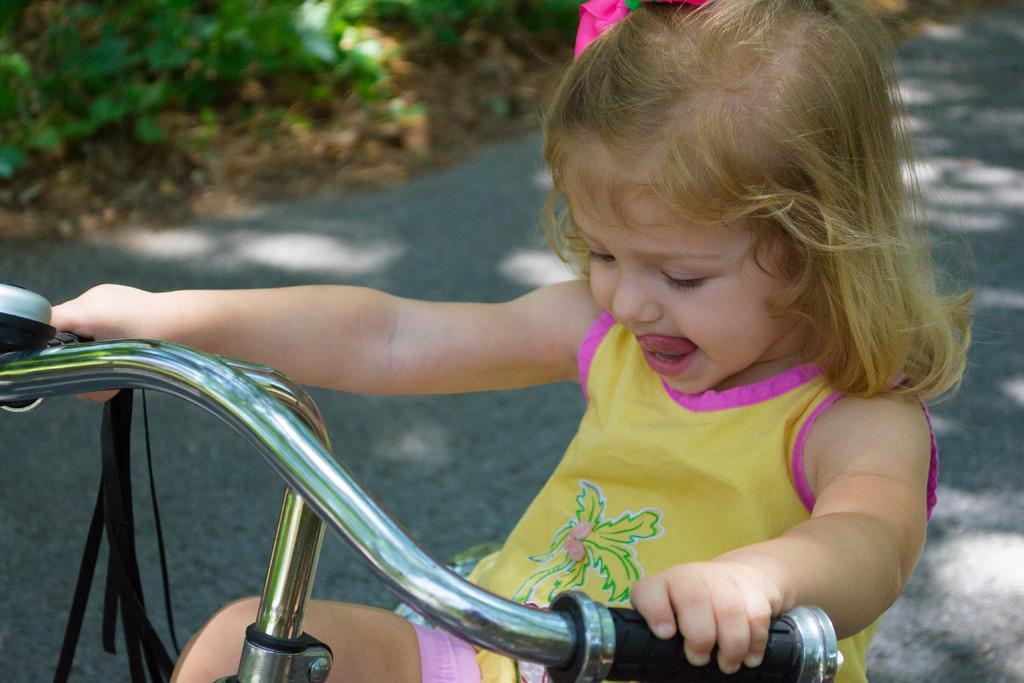Could you give a brief overview of what you see in this image? In this image there is a person riding bicycle on the road. At the back there are plants. 